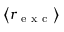Convert formula to latex. <formula><loc_0><loc_0><loc_500><loc_500>\left \langle r _ { e x c } \right \rangle</formula> 